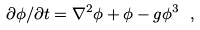Convert formula to latex. <formula><loc_0><loc_0><loc_500><loc_500>\partial \phi / \partial t = \nabla ^ { 2 } \phi + \phi - g \phi ^ { 3 } \ ,</formula> 